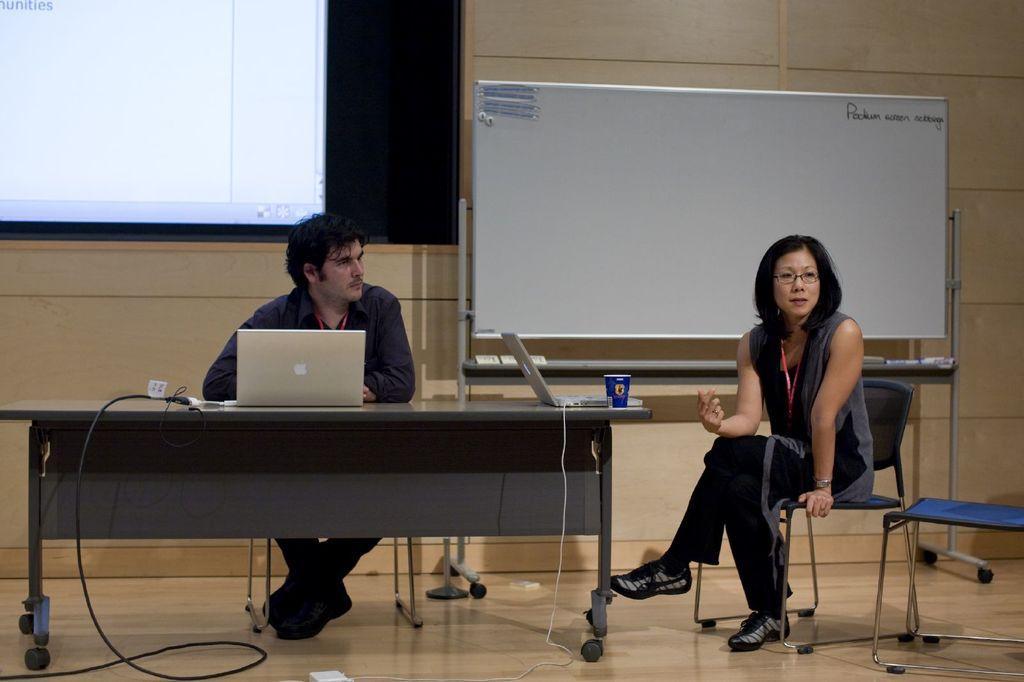In one or two sentences, can you explain what this image depicts? In this image I can see a man and a woman are sitting on chairs. Here on this table I can see two laptops and a cup. In the background I can see a white board and a projector's screen. 